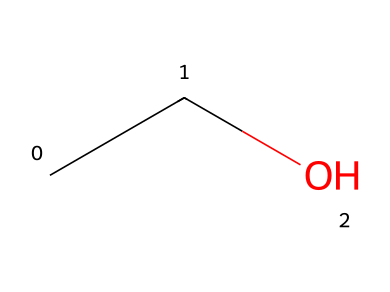What is the name of this chemical? The SMILES representation "CCO" corresponds to ethanol, which is a simple alcohol. Since the chemical structure indicates the presence of an ether group with the carbon and oxygen atoms, it is classified as ethyl ether.
Answer: ethyl ether How many carbon atoms are in this molecule? Analyzing the SMILES "CCO", it shows there are two carbon atoms represented by the two 'C's in the chain.
Answer: 2 What is the functional group present in this structure? The chemical structure includes an oxygen atom bonded to two carbon groups, which defines it as having an ether functional group.
Answer: ether What type of chemical bond connects the carbon and oxygen in this molecule? The connection between carbon and oxygen in the SMILES representation shows single bonds (as indicated by the absence of any symbols indicating double or triple bonds), thus it features single bonds.
Answer: single bonds Why is this compound classified as an ether? The classification as an ether stems from the fact that the molecule has the structure R-O-R', where R and R' are hydrocarbon chains; in this case, the oxygen atom is bonded to two ethyl groups (both represented by carbon atoms).
Answer: ether What is the molecular formula for this compound? Converting the SMILES "CCO" to its molecular formula involves counting the atoms: 2 carbon atoms (C2), 6 hydrogen atoms (H6), and 1 oxygen atom (O), leading to the formula C2H6O.
Answer: C2H6O 